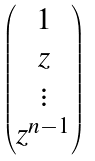<formula> <loc_0><loc_0><loc_500><loc_500>\begin{pmatrix} 1 \\ z \\ \vdots \\ z ^ { n - 1 } \end{pmatrix}</formula> 